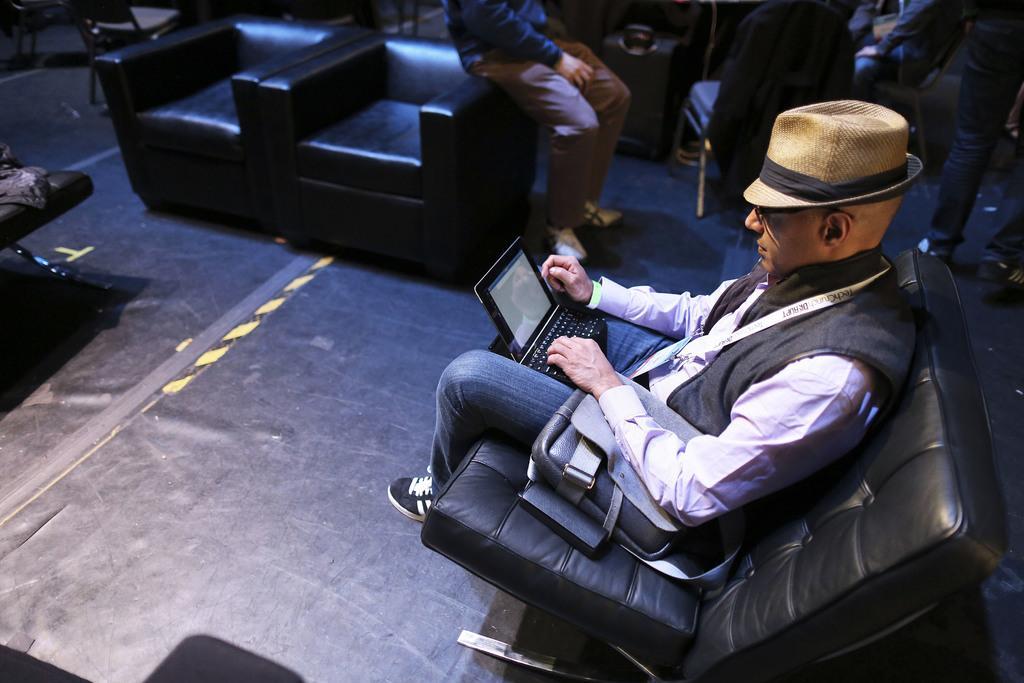Please provide a concise description of this image. here we see a man seated on a sofa and he wore cap on his head and sunglasses on his face. 